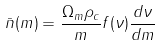Convert formula to latex. <formula><loc_0><loc_0><loc_500><loc_500>\bar { n } ( m ) = \frac { \Omega _ { m } \rho _ { c } } { m } f ( \nu ) \frac { d \nu } { d m }</formula> 